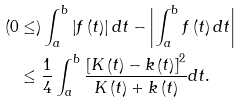<formula> <loc_0><loc_0><loc_500><loc_500>( 0 & \leq ) \int _ { a } ^ { b } \left | f \left ( t \right ) \right | d t - \left | \int _ { a } ^ { b } f \left ( t \right ) d t \right | \\ & \leq \frac { 1 } { 4 } \int _ { a } ^ { b } \frac { \left [ K \left ( t \right ) - k \left ( t \right ) \right ] ^ { 2 } } { K \left ( t \right ) + k \left ( t \right ) } d t .</formula> 